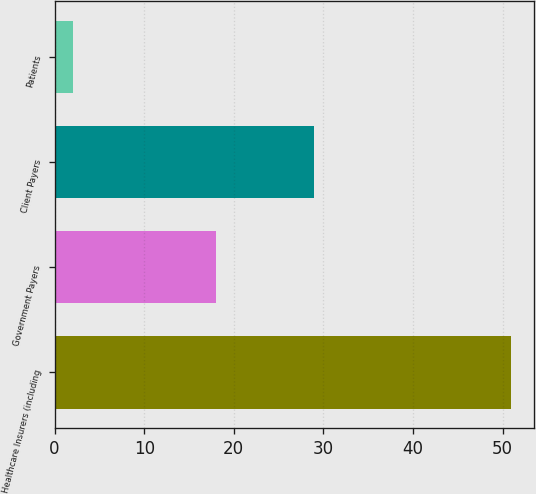<chart> <loc_0><loc_0><loc_500><loc_500><bar_chart><fcel>Healthcare Insurers (including<fcel>Government Payers<fcel>Client Payers<fcel>Patients<nl><fcel>51<fcel>18<fcel>29<fcel>2<nl></chart> 